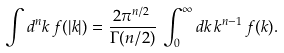<formula> <loc_0><loc_0><loc_500><loc_500>\int d ^ { n } k \, f ( | k | ) = \frac { 2 \pi ^ { n / 2 } } { \Gamma ( n / 2 ) } \, \int _ { 0 } ^ { \infty } d k \, k ^ { n - 1 } \, f ( k ) .</formula> 